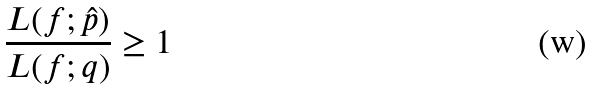<formula> <loc_0><loc_0><loc_500><loc_500>\frac { L ( f ; \hat { p } ) } { L ( f ; q ) } \geq 1</formula> 